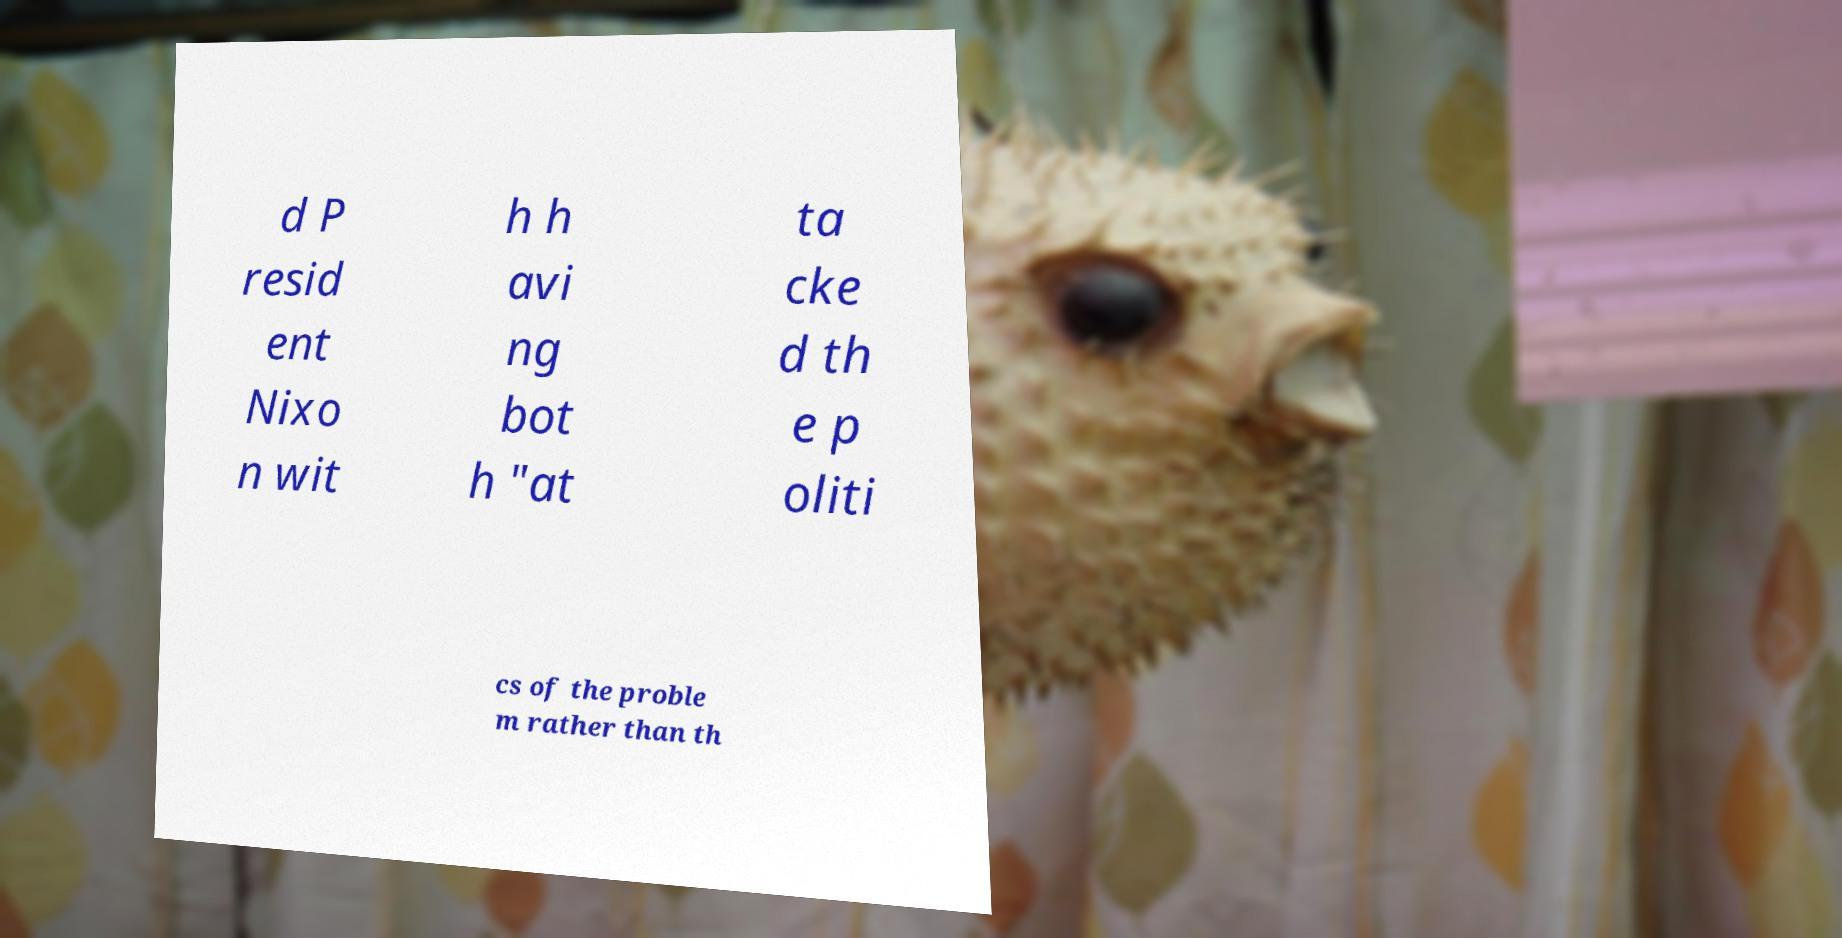I need the written content from this picture converted into text. Can you do that? d P resid ent Nixo n wit h h avi ng bot h "at ta cke d th e p oliti cs of the proble m rather than th 